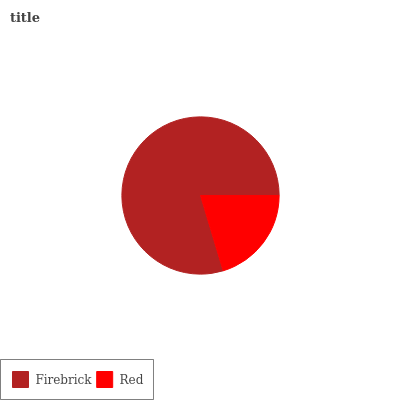Is Red the minimum?
Answer yes or no. Yes. Is Firebrick the maximum?
Answer yes or no. Yes. Is Red the maximum?
Answer yes or no. No. Is Firebrick greater than Red?
Answer yes or no. Yes. Is Red less than Firebrick?
Answer yes or no. Yes. Is Red greater than Firebrick?
Answer yes or no. No. Is Firebrick less than Red?
Answer yes or no. No. Is Firebrick the high median?
Answer yes or no. Yes. Is Red the low median?
Answer yes or no. Yes. Is Red the high median?
Answer yes or no. No. Is Firebrick the low median?
Answer yes or no. No. 